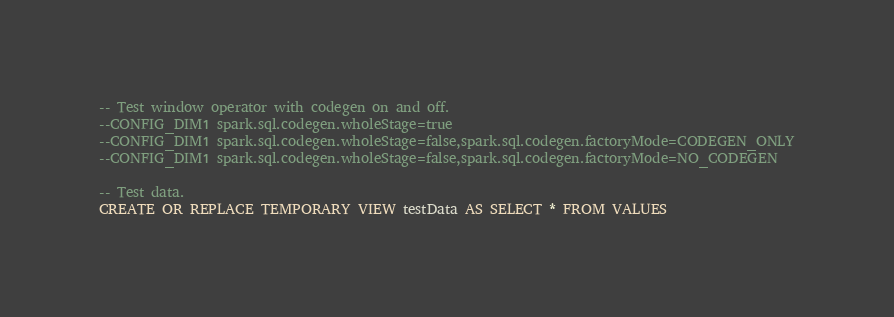<code> <loc_0><loc_0><loc_500><loc_500><_SQL_>-- Test window operator with codegen on and off.
--CONFIG_DIM1 spark.sql.codegen.wholeStage=true
--CONFIG_DIM1 spark.sql.codegen.wholeStage=false,spark.sql.codegen.factoryMode=CODEGEN_ONLY
--CONFIG_DIM1 spark.sql.codegen.wholeStage=false,spark.sql.codegen.factoryMode=NO_CODEGEN

-- Test data.
CREATE OR REPLACE TEMPORARY VIEW testData AS SELECT * FROM VALUES</code> 